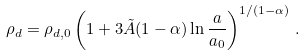<formula> <loc_0><loc_0><loc_500><loc_500>\rho _ { d } = \rho _ { d , 0 } \left ( 1 + 3 \tilde { A } ( 1 - \alpha ) \ln \frac { a } { a _ { 0 } } \right ) ^ { 1 / ( 1 - \alpha ) } \, .</formula> 